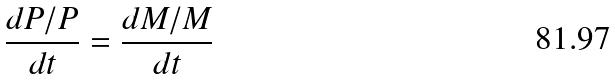<formula> <loc_0><loc_0><loc_500><loc_500>\frac { d P / P } { d t } = \frac { d M / M } { d t }</formula> 